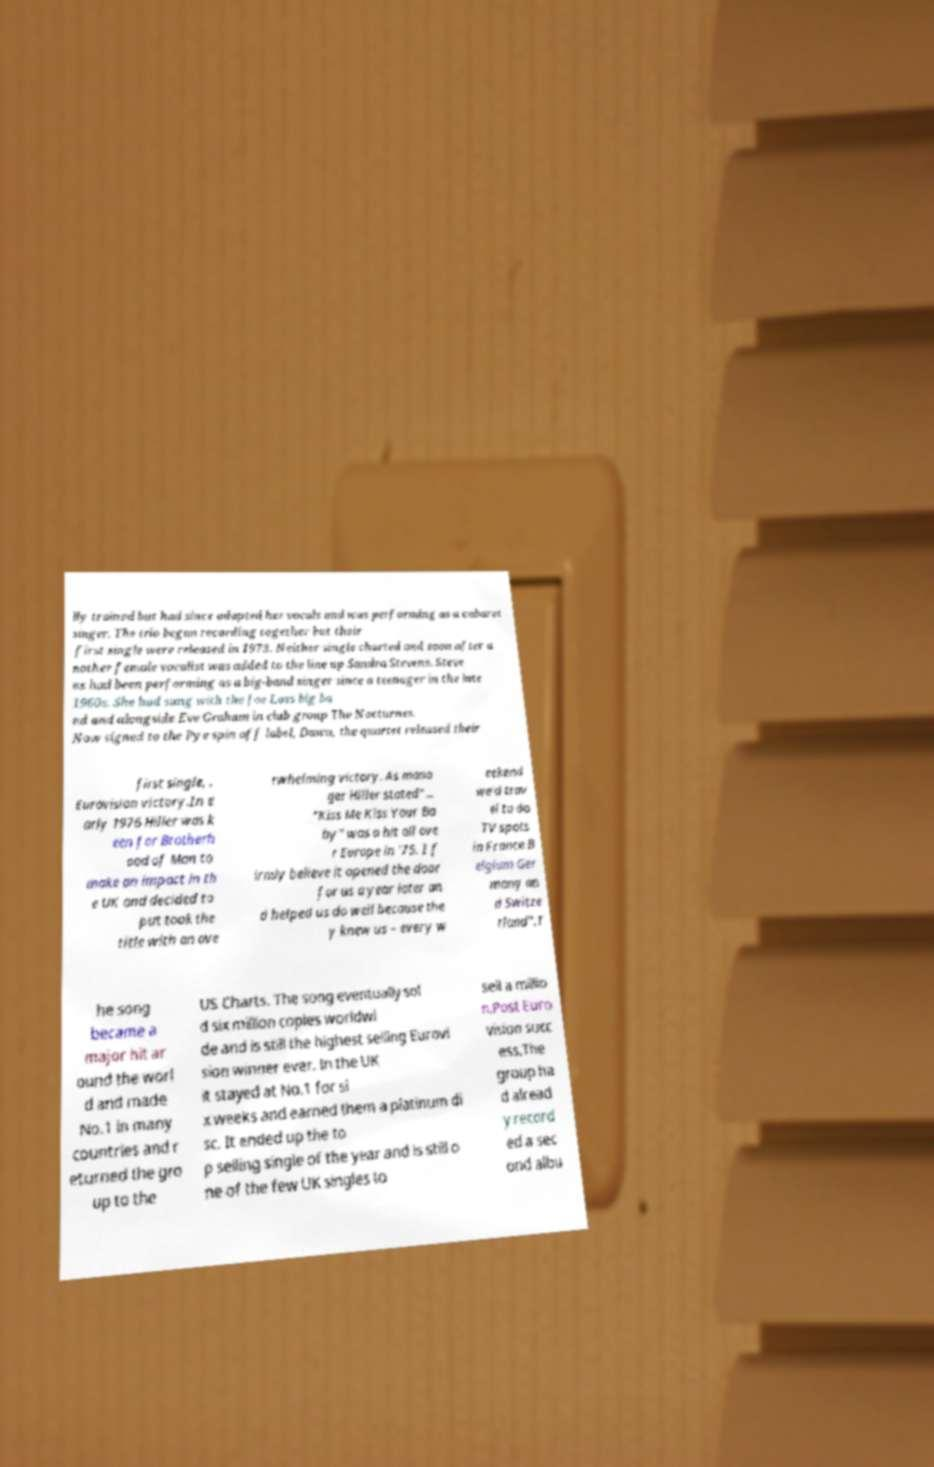Could you assist in decoding the text presented in this image and type it out clearly? lly trained but had since adapted her vocals and was performing as a cabaret singer. The trio began recording together but their first single were released in 1973. Neither single charted and soon after a nother female vocalist was added to the line up Sandra Stevens. Steve ns had been performing as a big-band singer since a teenager in the late 1960s. She had sung with the Joe Loss big ba nd and alongside Eve Graham in club group The Nocturnes. Now signed to the Pye spin off label, Dawn, the quartet released their first single, . Eurovision victory.In e arly 1976 Hiller was k een for Brotherh ood of Man to make an impact in th e UK and decided to put took the title with an ove rwhelming victory. As mana ger Hiller stated"... "Kiss Me Kiss Your Ba by" was a hit all ove r Europe in '75. I f irmly believe it opened the door for us a year later an d helped us do well because the y knew us – every w eekend we'd trav el to do TV spots in France B elgium Ger many an d Switze rland".T he song became a major hit ar ound the worl d and made No.1 in many countries and r eturned the gro up to the US Charts. The song eventually sol d six million copies worldwi de and is still the highest selling Eurovi sion winner ever. In the UK it stayed at No.1 for si x weeks and earned them a platinum di sc. It ended up the to p selling single of the year and is still o ne of the few UK singles to sell a millio n.Post Euro vision succ ess.The group ha d alread y record ed a sec ond albu 